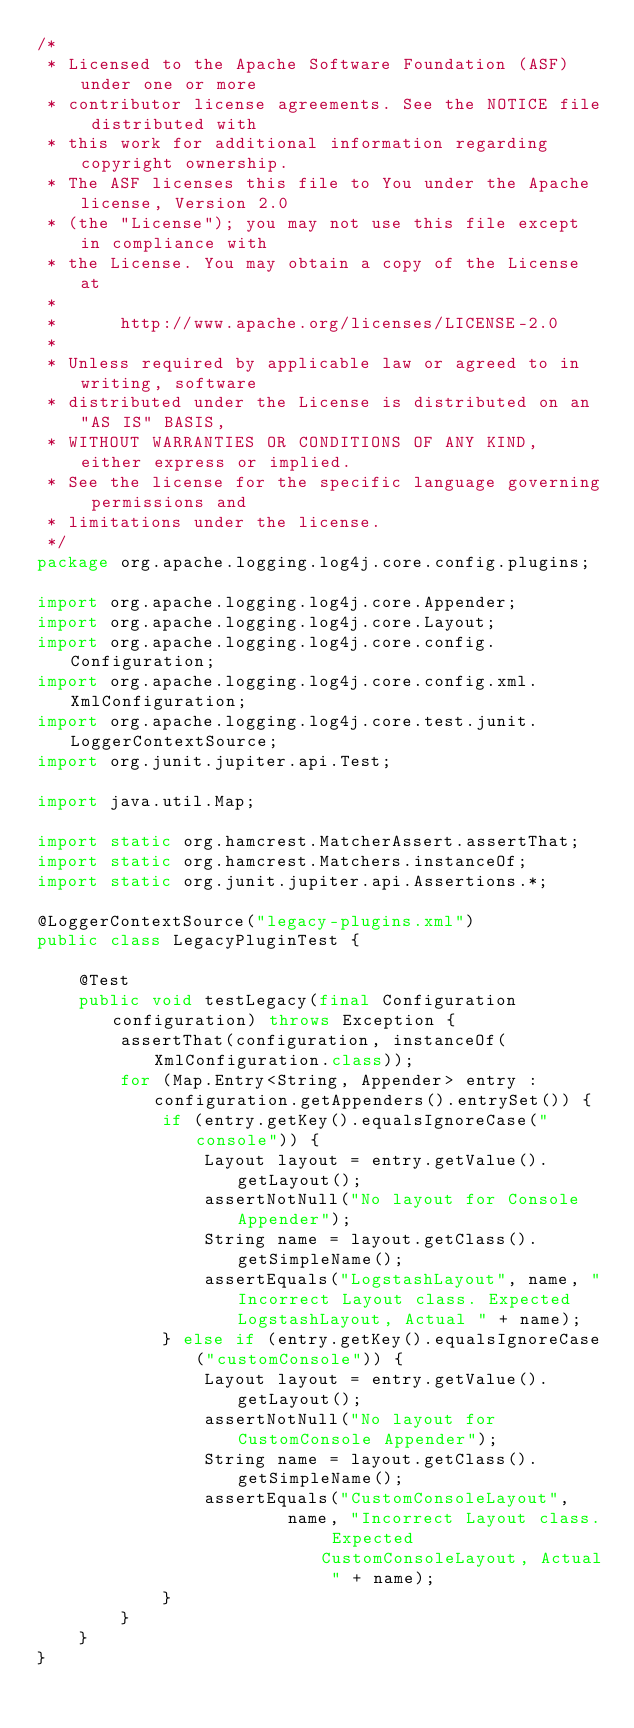Convert code to text. <code><loc_0><loc_0><loc_500><loc_500><_Java_>/*
 * Licensed to the Apache Software Foundation (ASF) under one or more
 * contributor license agreements. See the NOTICE file distributed with
 * this work for additional information regarding copyright ownership.
 * The ASF licenses this file to You under the Apache license, Version 2.0
 * (the "License"); you may not use this file except in compliance with
 * the License. You may obtain a copy of the License at
 *
 *      http://www.apache.org/licenses/LICENSE-2.0
 *
 * Unless required by applicable law or agreed to in writing, software
 * distributed under the License is distributed on an "AS IS" BASIS,
 * WITHOUT WARRANTIES OR CONDITIONS OF ANY KIND, either express or implied.
 * See the license for the specific language governing permissions and
 * limitations under the license.
 */
package org.apache.logging.log4j.core.config.plugins;

import org.apache.logging.log4j.core.Appender;
import org.apache.logging.log4j.core.Layout;
import org.apache.logging.log4j.core.config.Configuration;
import org.apache.logging.log4j.core.config.xml.XmlConfiguration;
import org.apache.logging.log4j.core.test.junit.LoggerContextSource;
import org.junit.jupiter.api.Test;

import java.util.Map;

import static org.hamcrest.MatcherAssert.assertThat;
import static org.hamcrest.Matchers.instanceOf;
import static org.junit.jupiter.api.Assertions.*;

@LoggerContextSource("legacy-plugins.xml")
public class LegacyPluginTest {

    @Test
    public void testLegacy(final Configuration configuration) throws Exception {
        assertThat(configuration, instanceOf(XmlConfiguration.class));
        for (Map.Entry<String, Appender> entry : configuration.getAppenders().entrySet()) {
            if (entry.getKey().equalsIgnoreCase("console")) {
                Layout layout = entry.getValue().getLayout();
                assertNotNull("No layout for Console Appender");
                String name = layout.getClass().getSimpleName();
                assertEquals("LogstashLayout", name, "Incorrect Layout class. Expected LogstashLayout, Actual " + name);
            } else if (entry.getKey().equalsIgnoreCase("customConsole")) {
                Layout layout = entry.getValue().getLayout();
                assertNotNull("No layout for CustomConsole Appender");
                String name = layout.getClass().getSimpleName();
                assertEquals("CustomConsoleLayout",
                        name, "Incorrect Layout class. Expected CustomConsoleLayout, Actual " + name);
            }
        }
    }
}
</code> 